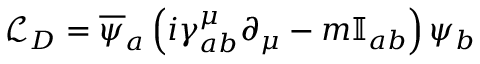Convert formula to latex. <formula><loc_0><loc_0><loc_500><loc_500>{ \mathcal { L } } _ { D } = { \overline { \psi } } _ { a } \left ( i \gamma _ { a b } ^ { \mu } \partial _ { \mu } - m \mathbb { I } _ { a b } \right ) \psi _ { b }</formula> 